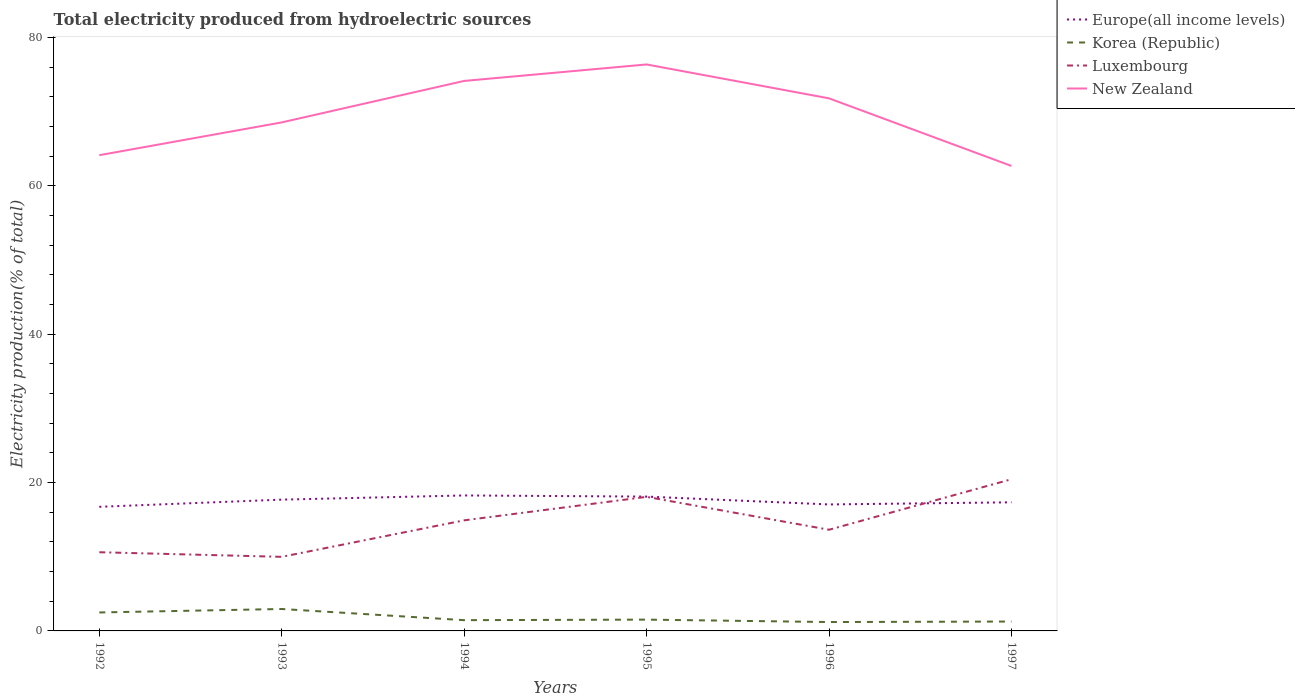How many different coloured lines are there?
Provide a short and direct response. 4. Does the line corresponding to Korea (Republic) intersect with the line corresponding to Luxembourg?
Offer a terse response. No. Across all years, what is the maximum total electricity produced in Europe(all income levels)?
Offer a very short reply. 16.73. In which year was the total electricity produced in Korea (Republic) maximum?
Your response must be concise. 1996. What is the total total electricity produced in New Zealand in the graph?
Provide a short and direct response. -4.42. What is the difference between the highest and the second highest total electricity produced in Europe(all income levels)?
Ensure brevity in your answer.  1.53. How many years are there in the graph?
Your response must be concise. 6. What is the difference between two consecutive major ticks on the Y-axis?
Offer a very short reply. 20. Are the values on the major ticks of Y-axis written in scientific E-notation?
Your answer should be compact. No. What is the title of the graph?
Ensure brevity in your answer.  Total electricity produced from hydroelectric sources. What is the label or title of the X-axis?
Your answer should be very brief. Years. What is the label or title of the Y-axis?
Give a very brief answer. Electricity production(% of total). What is the Electricity production(% of total) of Europe(all income levels) in 1992?
Offer a terse response. 16.73. What is the Electricity production(% of total) in Korea (Republic) in 1992?
Your answer should be very brief. 2.49. What is the Electricity production(% of total) of Luxembourg in 1992?
Your answer should be compact. 10.61. What is the Electricity production(% of total) of New Zealand in 1992?
Offer a very short reply. 64.12. What is the Electricity production(% of total) in Europe(all income levels) in 1993?
Ensure brevity in your answer.  17.69. What is the Electricity production(% of total) of Korea (Republic) in 1993?
Your answer should be compact. 2.96. What is the Electricity production(% of total) of Luxembourg in 1993?
Ensure brevity in your answer.  9.99. What is the Electricity production(% of total) of New Zealand in 1993?
Provide a short and direct response. 68.54. What is the Electricity production(% of total) in Europe(all income levels) in 1994?
Provide a succinct answer. 18.26. What is the Electricity production(% of total) of Korea (Republic) in 1994?
Make the answer very short. 1.45. What is the Electricity production(% of total) in Luxembourg in 1994?
Ensure brevity in your answer.  14.9. What is the Electricity production(% of total) of New Zealand in 1994?
Your answer should be very brief. 74.13. What is the Electricity production(% of total) in Europe(all income levels) in 1995?
Your response must be concise. 18.1. What is the Electricity production(% of total) in Korea (Republic) in 1995?
Offer a very short reply. 1.52. What is the Electricity production(% of total) of Luxembourg in 1995?
Provide a succinct answer. 18.07. What is the Electricity production(% of total) of New Zealand in 1995?
Your answer should be very brief. 76.35. What is the Electricity production(% of total) of Europe(all income levels) in 1996?
Your response must be concise. 17.05. What is the Electricity production(% of total) of Korea (Republic) in 1996?
Make the answer very short. 1.2. What is the Electricity production(% of total) in Luxembourg in 1996?
Give a very brief answer. 13.64. What is the Electricity production(% of total) of New Zealand in 1996?
Provide a short and direct response. 71.78. What is the Electricity production(% of total) in Europe(all income levels) in 1997?
Provide a succinct answer. 17.33. What is the Electricity production(% of total) of Korea (Republic) in 1997?
Provide a short and direct response. 1.27. What is the Electricity production(% of total) of Luxembourg in 1997?
Offer a terse response. 20.44. What is the Electricity production(% of total) in New Zealand in 1997?
Keep it short and to the point. 62.67. Across all years, what is the maximum Electricity production(% of total) of Europe(all income levels)?
Give a very brief answer. 18.26. Across all years, what is the maximum Electricity production(% of total) of Korea (Republic)?
Keep it short and to the point. 2.96. Across all years, what is the maximum Electricity production(% of total) in Luxembourg?
Keep it short and to the point. 20.44. Across all years, what is the maximum Electricity production(% of total) in New Zealand?
Offer a terse response. 76.35. Across all years, what is the minimum Electricity production(% of total) in Europe(all income levels)?
Offer a very short reply. 16.73. Across all years, what is the minimum Electricity production(% of total) in Korea (Republic)?
Your answer should be compact. 1.2. Across all years, what is the minimum Electricity production(% of total) in Luxembourg?
Keep it short and to the point. 9.99. Across all years, what is the minimum Electricity production(% of total) in New Zealand?
Offer a terse response. 62.67. What is the total Electricity production(% of total) of Europe(all income levels) in the graph?
Your answer should be very brief. 105.16. What is the total Electricity production(% of total) in Korea (Republic) in the graph?
Your response must be concise. 10.88. What is the total Electricity production(% of total) in Luxembourg in the graph?
Give a very brief answer. 87.65. What is the total Electricity production(% of total) of New Zealand in the graph?
Keep it short and to the point. 417.58. What is the difference between the Electricity production(% of total) of Europe(all income levels) in 1992 and that in 1993?
Keep it short and to the point. -0.97. What is the difference between the Electricity production(% of total) in Korea (Republic) in 1992 and that in 1993?
Provide a short and direct response. -0.47. What is the difference between the Electricity production(% of total) of Luxembourg in 1992 and that in 1993?
Keep it short and to the point. 0.62. What is the difference between the Electricity production(% of total) of New Zealand in 1992 and that in 1993?
Make the answer very short. -4.42. What is the difference between the Electricity production(% of total) in Europe(all income levels) in 1992 and that in 1994?
Keep it short and to the point. -1.53. What is the difference between the Electricity production(% of total) in Korea (Republic) in 1992 and that in 1994?
Provide a short and direct response. 1.04. What is the difference between the Electricity production(% of total) of Luxembourg in 1992 and that in 1994?
Provide a short and direct response. -4.3. What is the difference between the Electricity production(% of total) of New Zealand in 1992 and that in 1994?
Offer a terse response. -10.01. What is the difference between the Electricity production(% of total) in Europe(all income levels) in 1992 and that in 1995?
Your answer should be compact. -1.38. What is the difference between the Electricity production(% of total) of Korea (Republic) in 1992 and that in 1995?
Offer a very short reply. 0.97. What is the difference between the Electricity production(% of total) in Luxembourg in 1992 and that in 1995?
Keep it short and to the point. -7.46. What is the difference between the Electricity production(% of total) in New Zealand in 1992 and that in 1995?
Provide a short and direct response. -12.23. What is the difference between the Electricity production(% of total) of Europe(all income levels) in 1992 and that in 1996?
Offer a very short reply. -0.32. What is the difference between the Electricity production(% of total) in Korea (Republic) in 1992 and that in 1996?
Your answer should be very brief. 1.29. What is the difference between the Electricity production(% of total) in Luxembourg in 1992 and that in 1996?
Ensure brevity in your answer.  -3.03. What is the difference between the Electricity production(% of total) of New Zealand in 1992 and that in 1996?
Your answer should be very brief. -7.66. What is the difference between the Electricity production(% of total) in Europe(all income levels) in 1992 and that in 1997?
Give a very brief answer. -0.61. What is the difference between the Electricity production(% of total) in Korea (Republic) in 1992 and that in 1997?
Make the answer very short. 1.22. What is the difference between the Electricity production(% of total) of Luxembourg in 1992 and that in 1997?
Keep it short and to the point. -9.84. What is the difference between the Electricity production(% of total) of New Zealand in 1992 and that in 1997?
Your response must be concise. 1.45. What is the difference between the Electricity production(% of total) in Europe(all income levels) in 1993 and that in 1994?
Offer a terse response. -0.56. What is the difference between the Electricity production(% of total) of Korea (Republic) in 1993 and that in 1994?
Your answer should be compact. 1.5. What is the difference between the Electricity production(% of total) in Luxembourg in 1993 and that in 1994?
Provide a succinct answer. -4.92. What is the difference between the Electricity production(% of total) in New Zealand in 1993 and that in 1994?
Keep it short and to the point. -5.59. What is the difference between the Electricity production(% of total) in Europe(all income levels) in 1993 and that in 1995?
Your answer should be very brief. -0.41. What is the difference between the Electricity production(% of total) of Korea (Republic) in 1993 and that in 1995?
Your answer should be compact. 1.43. What is the difference between the Electricity production(% of total) in Luxembourg in 1993 and that in 1995?
Keep it short and to the point. -8.08. What is the difference between the Electricity production(% of total) of New Zealand in 1993 and that in 1995?
Offer a very short reply. -7.81. What is the difference between the Electricity production(% of total) in Europe(all income levels) in 1993 and that in 1996?
Offer a very short reply. 0.65. What is the difference between the Electricity production(% of total) in Korea (Republic) in 1993 and that in 1996?
Provide a succinct answer. 1.76. What is the difference between the Electricity production(% of total) of Luxembourg in 1993 and that in 1996?
Ensure brevity in your answer.  -3.65. What is the difference between the Electricity production(% of total) in New Zealand in 1993 and that in 1996?
Ensure brevity in your answer.  -3.24. What is the difference between the Electricity production(% of total) of Europe(all income levels) in 1993 and that in 1997?
Provide a short and direct response. 0.36. What is the difference between the Electricity production(% of total) of Korea (Republic) in 1993 and that in 1997?
Give a very brief answer. 1.69. What is the difference between the Electricity production(% of total) of Luxembourg in 1993 and that in 1997?
Your answer should be compact. -10.46. What is the difference between the Electricity production(% of total) in New Zealand in 1993 and that in 1997?
Give a very brief answer. 5.87. What is the difference between the Electricity production(% of total) of Europe(all income levels) in 1994 and that in 1995?
Provide a short and direct response. 0.15. What is the difference between the Electricity production(% of total) of Korea (Republic) in 1994 and that in 1995?
Give a very brief answer. -0.07. What is the difference between the Electricity production(% of total) of Luxembourg in 1994 and that in 1995?
Give a very brief answer. -3.17. What is the difference between the Electricity production(% of total) in New Zealand in 1994 and that in 1995?
Ensure brevity in your answer.  -2.22. What is the difference between the Electricity production(% of total) of Europe(all income levels) in 1994 and that in 1996?
Keep it short and to the point. 1.21. What is the difference between the Electricity production(% of total) of Korea (Republic) in 1994 and that in 1996?
Provide a succinct answer. 0.25. What is the difference between the Electricity production(% of total) in Luxembourg in 1994 and that in 1996?
Keep it short and to the point. 1.27. What is the difference between the Electricity production(% of total) of New Zealand in 1994 and that in 1996?
Give a very brief answer. 2.35. What is the difference between the Electricity production(% of total) in Europe(all income levels) in 1994 and that in 1997?
Give a very brief answer. 0.93. What is the difference between the Electricity production(% of total) of Korea (Republic) in 1994 and that in 1997?
Ensure brevity in your answer.  0.18. What is the difference between the Electricity production(% of total) of Luxembourg in 1994 and that in 1997?
Give a very brief answer. -5.54. What is the difference between the Electricity production(% of total) of New Zealand in 1994 and that in 1997?
Provide a succinct answer. 11.46. What is the difference between the Electricity production(% of total) in Europe(all income levels) in 1995 and that in 1996?
Make the answer very short. 1.06. What is the difference between the Electricity production(% of total) of Korea (Republic) in 1995 and that in 1996?
Make the answer very short. 0.33. What is the difference between the Electricity production(% of total) in Luxembourg in 1995 and that in 1996?
Keep it short and to the point. 4.43. What is the difference between the Electricity production(% of total) in New Zealand in 1995 and that in 1996?
Provide a succinct answer. 4.57. What is the difference between the Electricity production(% of total) of Europe(all income levels) in 1995 and that in 1997?
Make the answer very short. 0.77. What is the difference between the Electricity production(% of total) of Korea (Republic) in 1995 and that in 1997?
Provide a short and direct response. 0.26. What is the difference between the Electricity production(% of total) of Luxembourg in 1995 and that in 1997?
Your answer should be very brief. -2.37. What is the difference between the Electricity production(% of total) of New Zealand in 1995 and that in 1997?
Offer a very short reply. 13.68. What is the difference between the Electricity production(% of total) of Europe(all income levels) in 1996 and that in 1997?
Your answer should be very brief. -0.29. What is the difference between the Electricity production(% of total) of Korea (Republic) in 1996 and that in 1997?
Offer a very short reply. -0.07. What is the difference between the Electricity production(% of total) of Luxembourg in 1996 and that in 1997?
Your answer should be very brief. -6.81. What is the difference between the Electricity production(% of total) in New Zealand in 1996 and that in 1997?
Ensure brevity in your answer.  9.11. What is the difference between the Electricity production(% of total) of Europe(all income levels) in 1992 and the Electricity production(% of total) of Korea (Republic) in 1993?
Give a very brief answer. 13.77. What is the difference between the Electricity production(% of total) of Europe(all income levels) in 1992 and the Electricity production(% of total) of Luxembourg in 1993?
Make the answer very short. 6.74. What is the difference between the Electricity production(% of total) of Europe(all income levels) in 1992 and the Electricity production(% of total) of New Zealand in 1993?
Keep it short and to the point. -51.81. What is the difference between the Electricity production(% of total) in Korea (Republic) in 1992 and the Electricity production(% of total) in Luxembourg in 1993?
Provide a short and direct response. -7.5. What is the difference between the Electricity production(% of total) of Korea (Republic) in 1992 and the Electricity production(% of total) of New Zealand in 1993?
Ensure brevity in your answer.  -66.05. What is the difference between the Electricity production(% of total) in Luxembourg in 1992 and the Electricity production(% of total) in New Zealand in 1993?
Your response must be concise. -57.93. What is the difference between the Electricity production(% of total) of Europe(all income levels) in 1992 and the Electricity production(% of total) of Korea (Republic) in 1994?
Your answer should be very brief. 15.28. What is the difference between the Electricity production(% of total) of Europe(all income levels) in 1992 and the Electricity production(% of total) of Luxembourg in 1994?
Offer a terse response. 1.82. What is the difference between the Electricity production(% of total) in Europe(all income levels) in 1992 and the Electricity production(% of total) in New Zealand in 1994?
Ensure brevity in your answer.  -57.4. What is the difference between the Electricity production(% of total) of Korea (Republic) in 1992 and the Electricity production(% of total) of Luxembourg in 1994?
Give a very brief answer. -12.42. What is the difference between the Electricity production(% of total) of Korea (Republic) in 1992 and the Electricity production(% of total) of New Zealand in 1994?
Keep it short and to the point. -71.64. What is the difference between the Electricity production(% of total) in Luxembourg in 1992 and the Electricity production(% of total) in New Zealand in 1994?
Your answer should be very brief. -63.52. What is the difference between the Electricity production(% of total) of Europe(all income levels) in 1992 and the Electricity production(% of total) of Korea (Republic) in 1995?
Your answer should be very brief. 15.2. What is the difference between the Electricity production(% of total) in Europe(all income levels) in 1992 and the Electricity production(% of total) in Luxembourg in 1995?
Provide a succinct answer. -1.34. What is the difference between the Electricity production(% of total) of Europe(all income levels) in 1992 and the Electricity production(% of total) of New Zealand in 1995?
Your answer should be very brief. -59.62. What is the difference between the Electricity production(% of total) of Korea (Republic) in 1992 and the Electricity production(% of total) of Luxembourg in 1995?
Your response must be concise. -15.58. What is the difference between the Electricity production(% of total) in Korea (Republic) in 1992 and the Electricity production(% of total) in New Zealand in 1995?
Your answer should be compact. -73.86. What is the difference between the Electricity production(% of total) in Luxembourg in 1992 and the Electricity production(% of total) in New Zealand in 1995?
Your answer should be very brief. -65.74. What is the difference between the Electricity production(% of total) in Europe(all income levels) in 1992 and the Electricity production(% of total) in Korea (Republic) in 1996?
Your response must be concise. 15.53. What is the difference between the Electricity production(% of total) in Europe(all income levels) in 1992 and the Electricity production(% of total) in Luxembourg in 1996?
Offer a terse response. 3.09. What is the difference between the Electricity production(% of total) of Europe(all income levels) in 1992 and the Electricity production(% of total) of New Zealand in 1996?
Provide a short and direct response. -55.05. What is the difference between the Electricity production(% of total) in Korea (Republic) in 1992 and the Electricity production(% of total) in Luxembourg in 1996?
Provide a succinct answer. -11.15. What is the difference between the Electricity production(% of total) in Korea (Republic) in 1992 and the Electricity production(% of total) in New Zealand in 1996?
Your response must be concise. -69.29. What is the difference between the Electricity production(% of total) in Luxembourg in 1992 and the Electricity production(% of total) in New Zealand in 1996?
Provide a succinct answer. -61.17. What is the difference between the Electricity production(% of total) of Europe(all income levels) in 1992 and the Electricity production(% of total) of Korea (Republic) in 1997?
Offer a very short reply. 15.46. What is the difference between the Electricity production(% of total) of Europe(all income levels) in 1992 and the Electricity production(% of total) of Luxembourg in 1997?
Give a very brief answer. -3.72. What is the difference between the Electricity production(% of total) in Europe(all income levels) in 1992 and the Electricity production(% of total) in New Zealand in 1997?
Keep it short and to the point. -45.94. What is the difference between the Electricity production(% of total) of Korea (Republic) in 1992 and the Electricity production(% of total) of Luxembourg in 1997?
Your answer should be compact. -17.95. What is the difference between the Electricity production(% of total) in Korea (Republic) in 1992 and the Electricity production(% of total) in New Zealand in 1997?
Your answer should be very brief. -60.18. What is the difference between the Electricity production(% of total) in Luxembourg in 1992 and the Electricity production(% of total) in New Zealand in 1997?
Offer a very short reply. -52.06. What is the difference between the Electricity production(% of total) of Europe(all income levels) in 1993 and the Electricity production(% of total) of Korea (Republic) in 1994?
Give a very brief answer. 16.24. What is the difference between the Electricity production(% of total) of Europe(all income levels) in 1993 and the Electricity production(% of total) of Luxembourg in 1994?
Your answer should be very brief. 2.79. What is the difference between the Electricity production(% of total) in Europe(all income levels) in 1993 and the Electricity production(% of total) in New Zealand in 1994?
Ensure brevity in your answer.  -56.43. What is the difference between the Electricity production(% of total) in Korea (Republic) in 1993 and the Electricity production(% of total) in Luxembourg in 1994?
Your response must be concise. -11.95. What is the difference between the Electricity production(% of total) in Korea (Republic) in 1993 and the Electricity production(% of total) in New Zealand in 1994?
Your response must be concise. -71.17. What is the difference between the Electricity production(% of total) of Luxembourg in 1993 and the Electricity production(% of total) of New Zealand in 1994?
Offer a terse response. -64.14. What is the difference between the Electricity production(% of total) of Europe(all income levels) in 1993 and the Electricity production(% of total) of Korea (Republic) in 1995?
Offer a very short reply. 16.17. What is the difference between the Electricity production(% of total) in Europe(all income levels) in 1993 and the Electricity production(% of total) in Luxembourg in 1995?
Offer a terse response. -0.37. What is the difference between the Electricity production(% of total) of Europe(all income levels) in 1993 and the Electricity production(% of total) of New Zealand in 1995?
Offer a terse response. -58.65. What is the difference between the Electricity production(% of total) of Korea (Republic) in 1993 and the Electricity production(% of total) of Luxembourg in 1995?
Ensure brevity in your answer.  -15.11. What is the difference between the Electricity production(% of total) of Korea (Republic) in 1993 and the Electricity production(% of total) of New Zealand in 1995?
Your response must be concise. -73.39. What is the difference between the Electricity production(% of total) of Luxembourg in 1993 and the Electricity production(% of total) of New Zealand in 1995?
Your answer should be very brief. -66.36. What is the difference between the Electricity production(% of total) of Europe(all income levels) in 1993 and the Electricity production(% of total) of Korea (Republic) in 1996?
Provide a succinct answer. 16.5. What is the difference between the Electricity production(% of total) of Europe(all income levels) in 1993 and the Electricity production(% of total) of Luxembourg in 1996?
Your answer should be very brief. 4.06. What is the difference between the Electricity production(% of total) of Europe(all income levels) in 1993 and the Electricity production(% of total) of New Zealand in 1996?
Your answer should be very brief. -54.08. What is the difference between the Electricity production(% of total) of Korea (Republic) in 1993 and the Electricity production(% of total) of Luxembourg in 1996?
Give a very brief answer. -10.68. What is the difference between the Electricity production(% of total) in Korea (Republic) in 1993 and the Electricity production(% of total) in New Zealand in 1996?
Keep it short and to the point. -68.82. What is the difference between the Electricity production(% of total) in Luxembourg in 1993 and the Electricity production(% of total) in New Zealand in 1996?
Provide a short and direct response. -61.79. What is the difference between the Electricity production(% of total) in Europe(all income levels) in 1993 and the Electricity production(% of total) in Korea (Republic) in 1997?
Provide a short and direct response. 16.43. What is the difference between the Electricity production(% of total) in Europe(all income levels) in 1993 and the Electricity production(% of total) in Luxembourg in 1997?
Your response must be concise. -2.75. What is the difference between the Electricity production(% of total) of Europe(all income levels) in 1993 and the Electricity production(% of total) of New Zealand in 1997?
Your response must be concise. -44.97. What is the difference between the Electricity production(% of total) in Korea (Republic) in 1993 and the Electricity production(% of total) in Luxembourg in 1997?
Your answer should be compact. -17.49. What is the difference between the Electricity production(% of total) in Korea (Republic) in 1993 and the Electricity production(% of total) in New Zealand in 1997?
Provide a short and direct response. -59.71. What is the difference between the Electricity production(% of total) of Luxembourg in 1993 and the Electricity production(% of total) of New Zealand in 1997?
Keep it short and to the point. -52.68. What is the difference between the Electricity production(% of total) of Europe(all income levels) in 1994 and the Electricity production(% of total) of Korea (Republic) in 1995?
Make the answer very short. 16.73. What is the difference between the Electricity production(% of total) in Europe(all income levels) in 1994 and the Electricity production(% of total) in Luxembourg in 1995?
Your response must be concise. 0.19. What is the difference between the Electricity production(% of total) of Europe(all income levels) in 1994 and the Electricity production(% of total) of New Zealand in 1995?
Give a very brief answer. -58.09. What is the difference between the Electricity production(% of total) in Korea (Republic) in 1994 and the Electricity production(% of total) in Luxembourg in 1995?
Your response must be concise. -16.62. What is the difference between the Electricity production(% of total) of Korea (Republic) in 1994 and the Electricity production(% of total) of New Zealand in 1995?
Offer a very short reply. -74.9. What is the difference between the Electricity production(% of total) of Luxembourg in 1994 and the Electricity production(% of total) of New Zealand in 1995?
Provide a short and direct response. -61.44. What is the difference between the Electricity production(% of total) of Europe(all income levels) in 1994 and the Electricity production(% of total) of Korea (Republic) in 1996?
Make the answer very short. 17.06. What is the difference between the Electricity production(% of total) of Europe(all income levels) in 1994 and the Electricity production(% of total) of Luxembourg in 1996?
Your response must be concise. 4.62. What is the difference between the Electricity production(% of total) of Europe(all income levels) in 1994 and the Electricity production(% of total) of New Zealand in 1996?
Offer a terse response. -53.52. What is the difference between the Electricity production(% of total) of Korea (Republic) in 1994 and the Electricity production(% of total) of Luxembourg in 1996?
Offer a very short reply. -12.19. What is the difference between the Electricity production(% of total) in Korea (Republic) in 1994 and the Electricity production(% of total) in New Zealand in 1996?
Provide a short and direct response. -70.33. What is the difference between the Electricity production(% of total) in Luxembourg in 1994 and the Electricity production(% of total) in New Zealand in 1996?
Offer a terse response. -56.87. What is the difference between the Electricity production(% of total) in Europe(all income levels) in 1994 and the Electricity production(% of total) in Korea (Republic) in 1997?
Give a very brief answer. 16.99. What is the difference between the Electricity production(% of total) of Europe(all income levels) in 1994 and the Electricity production(% of total) of Luxembourg in 1997?
Ensure brevity in your answer.  -2.19. What is the difference between the Electricity production(% of total) in Europe(all income levels) in 1994 and the Electricity production(% of total) in New Zealand in 1997?
Your answer should be compact. -44.41. What is the difference between the Electricity production(% of total) in Korea (Republic) in 1994 and the Electricity production(% of total) in Luxembourg in 1997?
Keep it short and to the point. -18.99. What is the difference between the Electricity production(% of total) of Korea (Republic) in 1994 and the Electricity production(% of total) of New Zealand in 1997?
Provide a short and direct response. -61.22. What is the difference between the Electricity production(% of total) of Luxembourg in 1994 and the Electricity production(% of total) of New Zealand in 1997?
Give a very brief answer. -47.76. What is the difference between the Electricity production(% of total) in Europe(all income levels) in 1995 and the Electricity production(% of total) in Korea (Republic) in 1996?
Your answer should be very brief. 16.91. What is the difference between the Electricity production(% of total) in Europe(all income levels) in 1995 and the Electricity production(% of total) in Luxembourg in 1996?
Offer a very short reply. 4.47. What is the difference between the Electricity production(% of total) in Europe(all income levels) in 1995 and the Electricity production(% of total) in New Zealand in 1996?
Keep it short and to the point. -53.68. What is the difference between the Electricity production(% of total) of Korea (Republic) in 1995 and the Electricity production(% of total) of Luxembourg in 1996?
Ensure brevity in your answer.  -12.11. What is the difference between the Electricity production(% of total) in Korea (Republic) in 1995 and the Electricity production(% of total) in New Zealand in 1996?
Give a very brief answer. -70.26. What is the difference between the Electricity production(% of total) in Luxembourg in 1995 and the Electricity production(% of total) in New Zealand in 1996?
Offer a very short reply. -53.71. What is the difference between the Electricity production(% of total) in Europe(all income levels) in 1995 and the Electricity production(% of total) in Korea (Republic) in 1997?
Provide a short and direct response. 16.84. What is the difference between the Electricity production(% of total) of Europe(all income levels) in 1995 and the Electricity production(% of total) of Luxembourg in 1997?
Your answer should be very brief. -2.34. What is the difference between the Electricity production(% of total) of Europe(all income levels) in 1995 and the Electricity production(% of total) of New Zealand in 1997?
Your answer should be very brief. -44.57. What is the difference between the Electricity production(% of total) of Korea (Republic) in 1995 and the Electricity production(% of total) of Luxembourg in 1997?
Your response must be concise. -18.92. What is the difference between the Electricity production(% of total) in Korea (Republic) in 1995 and the Electricity production(% of total) in New Zealand in 1997?
Make the answer very short. -61.15. What is the difference between the Electricity production(% of total) in Luxembourg in 1995 and the Electricity production(% of total) in New Zealand in 1997?
Offer a terse response. -44.6. What is the difference between the Electricity production(% of total) in Europe(all income levels) in 1996 and the Electricity production(% of total) in Korea (Republic) in 1997?
Offer a very short reply. 15.78. What is the difference between the Electricity production(% of total) in Europe(all income levels) in 1996 and the Electricity production(% of total) in Luxembourg in 1997?
Offer a very short reply. -3.4. What is the difference between the Electricity production(% of total) of Europe(all income levels) in 1996 and the Electricity production(% of total) of New Zealand in 1997?
Offer a very short reply. -45.62. What is the difference between the Electricity production(% of total) in Korea (Republic) in 1996 and the Electricity production(% of total) in Luxembourg in 1997?
Your answer should be very brief. -19.25. What is the difference between the Electricity production(% of total) in Korea (Republic) in 1996 and the Electricity production(% of total) in New Zealand in 1997?
Make the answer very short. -61.47. What is the difference between the Electricity production(% of total) of Luxembourg in 1996 and the Electricity production(% of total) of New Zealand in 1997?
Make the answer very short. -49.03. What is the average Electricity production(% of total) of Europe(all income levels) per year?
Your answer should be compact. 17.53. What is the average Electricity production(% of total) of Korea (Republic) per year?
Provide a short and direct response. 1.81. What is the average Electricity production(% of total) in Luxembourg per year?
Your response must be concise. 14.61. What is the average Electricity production(% of total) in New Zealand per year?
Provide a short and direct response. 69.6. In the year 1992, what is the difference between the Electricity production(% of total) in Europe(all income levels) and Electricity production(% of total) in Korea (Republic)?
Make the answer very short. 14.24. In the year 1992, what is the difference between the Electricity production(% of total) of Europe(all income levels) and Electricity production(% of total) of Luxembourg?
Provide a short and direct response. 6.12. In the year 1992, what is the difference between the Electricity production(% of total) in Europe(all income levels) and Electricity production(% of total) in New Zealand?
Your answer should be compact. -47.39. In the year 1992, what is the difference between the Electricity production(% of total) in Korea (Republic) and Electricity production(% of total) in Luxembourg?
Offer a very short reply. -8.12. In the year 1992, what is the difference between the Electricity production(% of total) in Korea (Republic) and Electricity production(% of total) in New Zealand?
Offer a very short reply. -61.63. In the year 1992, what is the difference between the Electricity production(% of total) of Luxembourg and Electricity production(% of total) of New Zealand?
Provide a succinct answer. -53.51. In the year 1993, what is the difference between the Electricity production(% of total) of Europe(all income levels) and Electricity production(% of total) of Korea (Republic)?
Keep it short and to the point. 14.74. In the year 1993, what is the difference between the Electricity production(% of total) in Europe(all income levels) and Electricity production(% of total) in Luxembourg?
Provide a succinct answer. 7.71. In the year 1993, what is the difference between the Electricity production(% of total) in Europe(all income levels) and Electricity production(% of total) in New Zealand?
Offer a terse response. -50.84. In the year 1993, what is the difference between the Electricity production(% of total) in Korea (Republic) and Electricity production(% of total) in Luxembourg?
Provide a short and direct response. -7.03. In the year 1993, what is the difference between the Electricity production(% of total) in Korea (Republic) and Electricity production(% of total) in New Zealand?
Your answer should be very brief. -65.58. In the year 1993, what is the difference between the Electricity production(% of total) in Luxembourg and Electricity production(% of total) in New Zealand?
Give a very brief answer. -58.55. In the year 1994, what is the difference between the Electricity production(% of total) in Europe(all income levels) and Electricity production(% of total) in Korea (Republic)?
Your answer should be very brief. 16.81. In the year 1994, what is the difference between the Electricity production(% of total) in Europe(all income levels) and Electricity production(% of total) in Luxembourg?
Your answer should be compact. 3.35. In the year 1994, what is the difference between the Electricity production(% of total) of Europe(all income levels) and Electricity production(% of total) of New Zealand?
Your answer should be very brief. -55.87. In the year 1994, what is the difference between the Electricity production(% of total) in Korea (Republic) and Electricity production(% of total) in Luxembourg?
Provide a succinct answer. -13.45. In the year 1994, what is the difference between the Electricity production(% of total) of Korea (Republic) and Electricity production(% of total) of New Zealand?
Make the answer very short. -72.68. In the year 1994, what is the difference between the Electricity production(% of total) in Luxembourg and Electricity production(% of total) in New Zealand?
Your answer should be compact. -59.22. In the year 1995, what is the difference between the Electricity production(% of total) of Europe(all income levels) and Electricity production(% of total) of Korea (Republic)?
Provide a succinct answer. 16.58. In the year 1995, what is the difference between the Electricity production(% of total) in Europe(all income levels) and Electricity production(% of total) in Luxembourg?
Your response must be concise. 0.03. In the year 1995, what is the difference between the Electricity production(% of total) in Europe(all income levels) and Electricity production(% of total) in New Zealand?
Provide a succinct answer. -58.24. In the year 1995, what is the difference between the Electricity production(% of total) of Korea (Republic) and Electricity production(% of total) of Luxembourg?
Offer a terse response. -16.55. In the year 1995, what is the difference between the Electricity production(% of total) of Korea (Republic) and Electricity production(% of total) of New Zealand?
Your answer should be compact. -74.82. In the year 1995, what is the difference between the Electricity production(% of total) of Luxembourg and Electricity production(% of total) of New Zealand?
Give a very brief answer. -58.28. In the year 1996, what is the difference between the Electricity production(% of total) of Europe(all income levels) and Electricity production(% of total) of Korea (Republic)?
Keep it short and to the point. 15.85. In the year 1996, what is the difference between the Electricity production(% of total) of Europe(all income levels) and Electricity production(% of total) of Luxembourg?
Your answer should be compact. 3.41. In the year 1996, what is the difference between the Electricity production(% of total) in Europe(all income levels) and Electricity production(% of total) in New Zealand?
Offer a very short reply. -54.73. In the year 1996, what is the difference between the Electricity production(% of total) of Korea (Republic) and Electricity production(% of total) of Luxembourg?
Your answer should be very brief. -12.44. In the year 1996, what is the difference between the Electricity production(% of total) in Korea (Republic) and Electricity production(% of total) in New Zealand?
Give a very brief answer. -70.58. In the year 1996, what is the difference between the Electricity production(% of total) of Luxembourg and Electricity production(% of total) of New Zealand?
Offer a very short reply. -58.14. In the year 1997, what is the difference between the Electricity production(% of total) in Europe(all income levels) and Electricity production(% of total) in Korea (Republic)?
Your answer should be very brief. 16.07. In the year 1997, what is the difference between the Electricity production(% of total) of Europe(all income levels) and Electricity production(% of total) of Luxembourg?
Give a very brief answer. -3.11. In the year 1997, what is the difference between the Electricity production(% of total) in Europe(all income levels) and Electricity production(% of total) in New Zealand?
Provide a short and direct response. -45.34. In the year 1997, what is the difference between the Electricity production(% of total) in Korea (Republic) and Electricity production(% of total) in Luxembourg?
Offer a very short reply. -19.18. In the year 1997, what is the difference between the Electricity production(% of total) of Korea (Republic) and Electricity production(% of total) of New Zealand?
Keep it short and to the point. -61.4. In the year 1997, what is the difference between the Electricity production(% of total) in Luxembourg and Electricity production(% of total) in New Zealand?
Provide a succinct answer. -42.23. What is the ratio of the Electricity production(% of total) in Europe(all income levels) in 1992 to that in 1993?
Provide a succinct answer. 0.95. What is the ratio of the Electricity production(% of total) in Korea (Republic) in 1992 to that in 1993?
Provide a short and direct response. 0.84. What is the ratio of the Electricity production(% of total) of Luxembourg in 1992 to that in 1993?
Provide a short and direct response. 1.06. What is the ratio of the Electricity production(% of total) in New Zealand in 1992 to that in 1993?
Keep it short and to the point. 0.94. What is the ratio of the Electricity production(% of total) in Europe(all income levels) in 1992 to that in 1994?
Give a very brief answer. 0.92. What is the ratio of the Electricity production(% of total) in Korea (Republic) in 1992 to that in 1994?
Your answer should be compact. 1.72. What is the ratio of the Electricity production(% of total) of Luxembourg in 1992 to that in 1994?
Ensure brevity in your answer.  0.71. What is the ratio of the Electricity production(% of total) in New Zealand in 1992 to that in 1994?
Offer a very short reply. 0.86. What is the ratio of the Electricity production(% of total) of Europe(all income levels) in 1992 to that in 1995?
Keep it short and to the point. 0.92. What is the ratio of the Electricity production(% of total) in Korea (Republic) in 1992 to that in 1995?
Keep it short and to the point. 1.63. What is the ratio of the Electricity production(% of total) in Luxembourg in 1992 to that in 1995?
Offer a very short reply. 0.59. What is the ratio of the Electricity production(% of total) of New Zealand in 1992 to that in 1995?
Offer a terse response. 0.84. What is the ratio of the Electricity production(% of total) of Europe(all income levels) in 1992 to that in 1996?
Provide a short and direct response. 0.98. What is the ratio of the Electricity production(% of total) of Korea (Republic) in 1992 to that in 1996?
Your answer should be compact. 2.08. What is the ratio of the Electricity production(% of total) of Luxembourg in 1992 to that in 1996?
Provide a short and direct response. 0.78. What is the ratio of the Electricity production(% of total) in New Zealand in 1992 to that in 1996?
Offer a very short reply. 0.89. What is the ratio of the Electricity production(% of total) of Europe(all income levels) in 1992 to that in 1997?
Provide a succinct answer. 0.96. What is the ratio of the Electricity production(% of total) of Korea (Republic) in 1992 to that in 1997?
Your response must be concise. 1.97. What is the ratio of the Electricity production(% of total) of Luxembourg in 1992 to that in 1997?
Ensure brevity in your answer.  0.52. What is the ratio of the Electricity production(% of total) of New Zealand in 1992 to that in 1997?
Provide a short and direct response. 1.02. What is the ratio of the Electricity production(% of total) in Europe(all income levels) in 1993 to that in 1994?
Ensure brevity in your answer.  0.97. What is the ratio of the Electricity production(% of total) of Korea (Republic) in 1993 to that in 1994?
Offer a terse response. 2.04. What is the ratio of the Electricity production(% of total) in Luxembourg in 1993 to that in 1994?
Keep it short and to the point. 0.67. What is the ratio of the Electricity production(% of total) in New Zealand in 1993 to that in 1994?
Ensure brevity in your answer.  0.92. What is the ratio of the Electricity production(% of total) in Europe(all income levels) in 1993 to that in 1995?
Offer a terse response. 0.98. What is the ratio of the Electricity production(% of total) in Korea (Republic) in 1993 to that in 1995?
Ensure brevity in your answer.  1.94. What is the ratio of the Electricity production(% of total) of Luxembourg in 1993 to that in 1995?
Your answer should be compact. 0.55. What is the ratio of the Electricity production(% of total) of New Zealand in 1993 to that in 1995?
Keep it short and to the point. 0.9. What is the ratio of the Electricity production(% of total) in Europe(all income levels) in 1993 to that in 1996?
Your answer should be very brief. 1.04. What is the ratio of the Electricity production(% of total) in Korea (Republic) in 1993 to that in 1996?
Your answer should be compact. 2.47. What is the ratio of the Electricity production(% of total) in Luxembourg in 1993 to that in 1996?
Ensure brevity in your answer.  0.73. What is the ratio of the Electricity production(% of total) in New Zealand in 1993 to that in 1996?
Offer a very short reply. 0.95. What is the ratio of the Electricity production(% of total) of Europe(all income levels) in 1993 to that in 1997?
Keep it short and to the point. 1.02. What is the ratio of the Electricity production(% of total) in Korea (Republic) in 1993 to that in 1997?
Your answer should be compact. 2.33. What is the ratio of the Electricity production(% of total) of Luxembourg in 1993 to that in 1997?
Provide a succinct answer. 0.49. What is the ratio of the Electricity production(% of total) in New Zealand in 1993 to that in 1997?
Offer a terse response. 1.09. What is the ratio of the Electricity production(% of total) in Europe(all income levels) in 1994 to that in 1995?
Your answer should be compact. 1.01. What is the ratio of the Electricity production(% of total) of Korea (Republic) in 1994 to that in 1995?
Make the answer very short. 0.95. What is the ratio of the Electricity production(% of total) of Luxembourg in 1994 to that in 1995?
Your answer should be very brief. 0.82. What is the ratio of the Electricity production(% of total) of New Zealand in 1994 to that in 1995?
Make the answer very short. 0.97. What is the ratio of the Electricity production(% of total) of Europe(all income levels) in 1994 to that in 1996?
Your response must be concise. 1.07. What is the ratio of the Electricity production(% of total) of Korea (Republic) in 1994 to that in 1996?
Make the answer very short. 1.21. What is the ratio of the Electricity production(% of total) of Luxembourg in 1994 to that in 1996?
Keep it short and to the point. 1.09. What is the ratio of the Electricity production(% of total) in New Zealand in 1994 to that in 1996?
Provide a short and direct response. 1.03. What is the ratio of the Electricity production(% of total) of Europe(all income levels) in 1994 to that in 1997?
Offer a terse response. 1.05. What is the ratio of the Electricity production(% of total) of Korea (Republic) in 1994 to that in 1997?
Provide a succinct answer. 1.15. What is the ratio of the Electricity production(% of total) of Luxembourg in 1994 to that in 1997?
Offer a very short reply. 0.73. What is the ratio of the Electricity production(% of total) in New Zealand in 1994 to that in 1997?
Keep it short and to the point. 1.18. What is the ratio of the Electricity production(% of total) in Europe(all income levels) in 1995 to that in 1996?
Provide a succinct answer. 1.06. What is the ratio of the Electricity production(% of total) in Korea (Republic) in 1995 to that in 1996?
Give a very brief answer. 1.27. What is the ratio of the Electricity production(% of total) of Luxembourg in 1995 to that in 1996?
Give a very brief answer. 1.33. What is the ratio of the Electricity production(% of total) of New Zealand in 1995 to that in 1996?
Make the answer very short. 1.06. What is the ratio of the Electricity production(% of total) in Europe(all income levels) in 1995 to that in 1997?
Your response must be concise. 1.04. What is the ratio of the Electricity production(% of total) in Korea (Republic) in 1995 to that in 1997?
Provide a short and direct response. 1.2. What is the ratio of the Electricity production(% of total) in Luxembourg in 1995 to that in 1997?
Give a very brief answer. 0.88. What is the ratio of the Electricity production(% of total) in New Zealand in 1995 to that in 1997?
Your answer should be compact. 1.22. What is the ratio of the Electricity production(% of total) of Europe(all income levels) in 1996 to that in 1997?
Your answer should be very brief. 0.98. What is the ratio of the Electricity production(% of total) in Korea (Republic) in 1996 to that in 1997?
Keep it short and to the point. 0.94. What is the ratio of the Electricity production(% of total) in Luxembourg in 1996 to that in 1997?
Your answer should be compact. 0.67. What is the ratio of the Electricity production(% of total) of New Zealand in 1996 to that in 1997?
Give a very brief answer. 1.15. What is the difference between the highest and the second highest Electricity production(% of total) in Europe(all income levels)?
Offer a very short reply. 0.15. What is the difference between the highest and the second highest Electricity production(% of total) of Korea (Republic)?
Ensure brevity in your answer.  0.47. What is the difference between the highest and the second highest Electricity production(% of total) of Luxembourg?
Ensure brevity in your answer.  2.37. What is the difference between the highest and the second highest Electricity production(% of total) in New Zealand?
Provide a succinct answer. 2.22. What is the difference between the highest and the lowest Electricity production(% of total) of Europe(all income levels)?
Keep it short and to the point. 1.53. What is the difference between the highest and the lowest Electricity production(% of total) of Korea (Republic)?
Offer a terse response. 1.76. What is the difference between the highest and the lowest Electricity production(% of total) in Luxembourg?
Provide a short and direct response. 10.46. What is the difference between the highest and the lowest Electricity production(% of total) in New Zealand?
Keep it short and to the point. 13.68. 